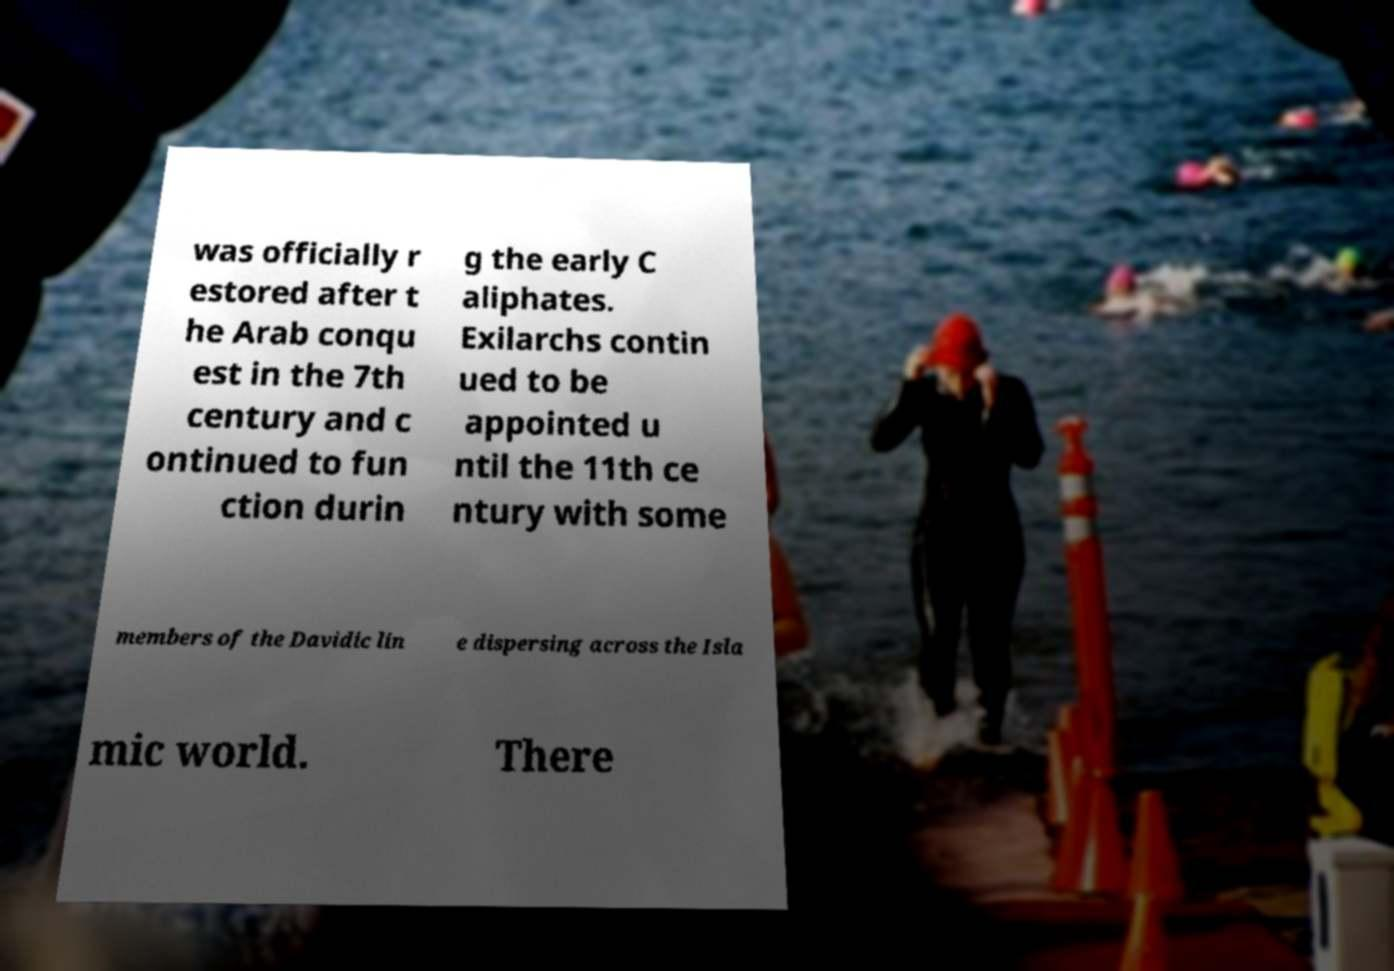For documentation purposes, I need the text within this image transcribed. Could you provide that? was officially r estored after t he Arab conqu est in the 7th century and c ontinued to fun ction durin g the early C aliphates. Exilarchs contin ued to be appointed u ntil the 11th ce ntury with some members of the Davidic lin e dispersing across the Isla mic world. There 